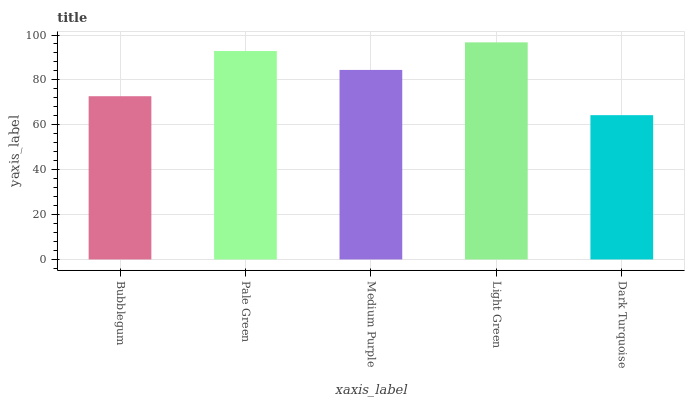Is Dark Turquoise the minimum?
Answer yes or no. Yes. Is Light Green the maximum?
Answer yes or no. Yes. Is Pale Green the minimum?
Answer yes or no. No. Is Pale Green the maximum?
Answer yes or no. No. Is Pale Green greater than Bubblegum?
Answer yes or no. Yes. Is Bubblegum less than Pale Green?
Answer yes or no. Yes. Is Bubblegum greater than Pale Green?
Answer yes or no. No. Is Pale Green less than Bubblegum?
Answer yes or no. No. Is Medium Purple the high median?
Answer yes or no. Yes. Is Medium Purple the low median?
Answer yes or no. Yes. Is Bubblegum the high median?
Answer yes or no. No. Is Light Green the low median?
Answer yes or no. No. 